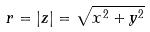Convert formula to latex. <formula><loc_0><loc_0><loc_500><loc_500>r = | z | = \sqrt { x ^ { 2 } + y ^ { 2 } }</formula> 